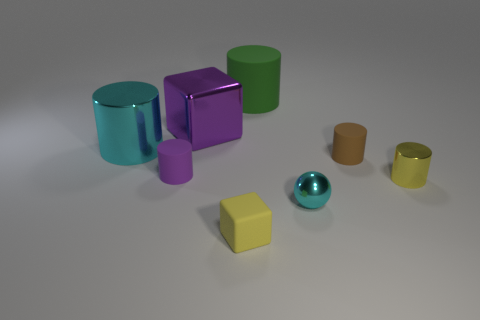Subtract all yellow cylinders. How many cylinders are left? 4 Subtract all tiny purple matte cylinders. How many cylinders are left? 4 Subtract all red cylinders. Subtract all cyan balls. How many cylinders are left? 5 Add 2 yellow cylinders. How many objects exist? 10 Subtract all cubes. How many objects are left? 6 Add 8 small yellow cylinders. How many small yellow cylinders exist? 9 Subtract 1 cyan spheres. How many objects are left? 7 Subtract all cyan metallic objects. Subtract all purple objects. How many objects are left? 4 Add 6 tiny purple cylinders. How many tiny purple cylinders are left? 7 